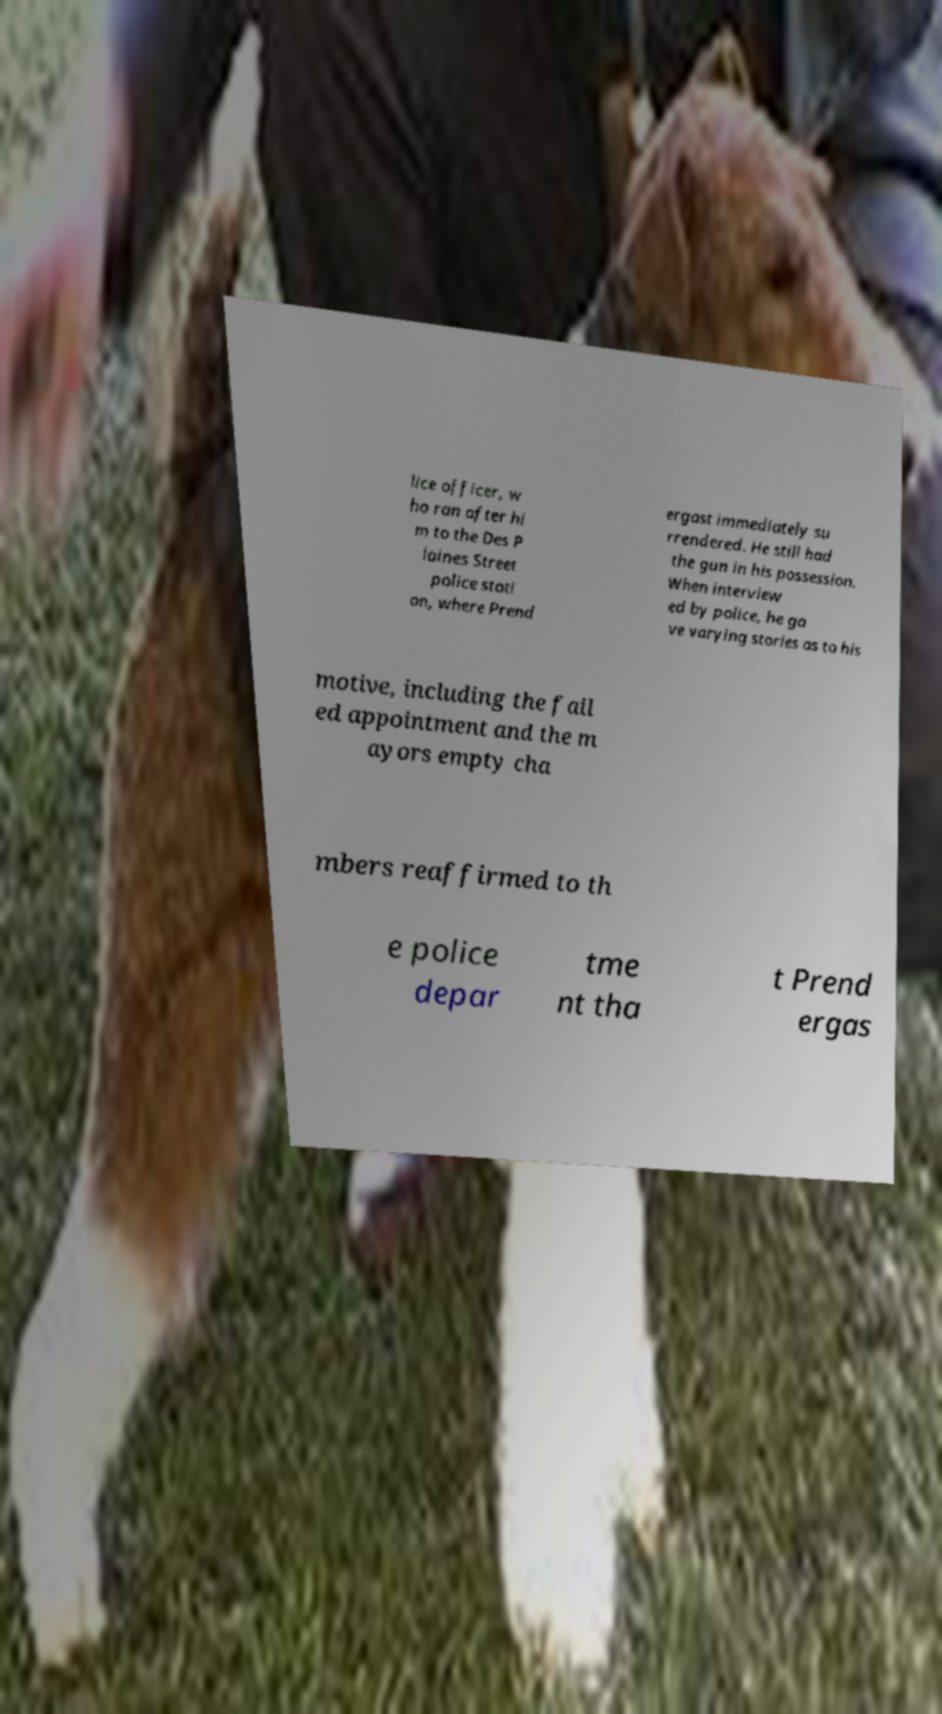Can you accurately transcribe the text from the provided image for me? lice officer, w ho ran after hi m to the Des P laines Street police stati on, where Prend ergast immediately su rrendered. He still had the gun in his possession. When interview ed by police, he ga ve varying stories as to his motive, including the fail ed appointment and the m ayors empty cha mbers reaffirmed to th e police depar tme nt tha t Prend ergas 